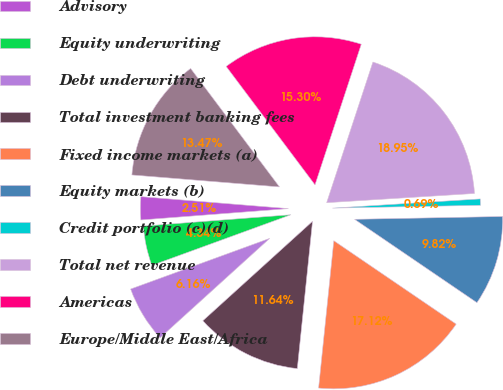<chart> <loc_0><loc_0><loc_500><loc_500><pie_chart><fcel>Advisory<fcel>Equity underwriting<fcel>Debt underwriting<fcel>Total investment banking fees<fcel>Fixed income markets (a)<fcel>Equity markets (b)<fcel>Credit portfolio (c)(d)<fcel>Total net revenue<fcel>Americas<fcel>Europe/Middle East/Africa<nl><fcel>2.51%<fcel>4.34%<fcel>6.16%<fcel>11.64%<fcel>17.12%<fcel>9.82%<fcel>0.69%<fcel>18.95%<fcel>15.3%<fcel>13.47%<nl></chart> 